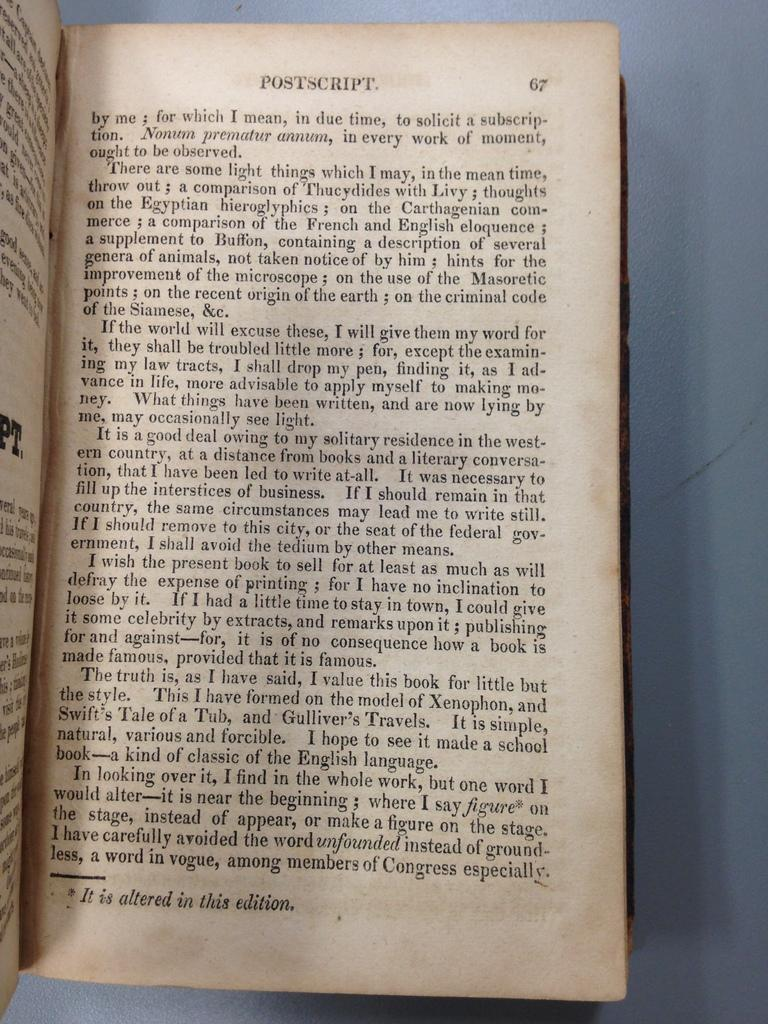<image>
Provide a brief description of the given image. An old text book open to a page titled Postscript. 